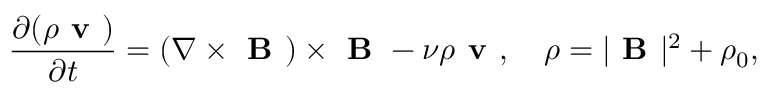<formula> <loc_0><loc_0><loc_500><loc_500>\frac { \partial ( \rho v ) } { \partial t } = ( \nabla \times B ) \times B - \nu \rho v , \quad \rho = | B | ^ { 2 } + \rho _ { 0 } ,</formula> 